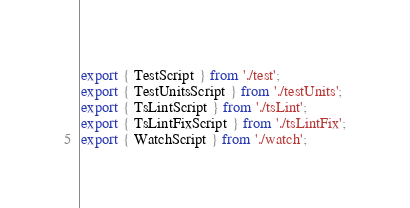Convert code to text. <code><loc_0><loc_0><loc_500><loc_500><_TypeScript_>export { TestScript } from './test';
export { TestUnitsScript } from './testUnits';
export { TsLintScript } from './tsLint';
export { TsLintFixScript } from './tsLintFix';
export { WatchScript } from './watch';
</code> 